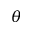Convert formula to latex. <formula><loc_0><loc_0><loc_500><loc_500>\theta</formula> 